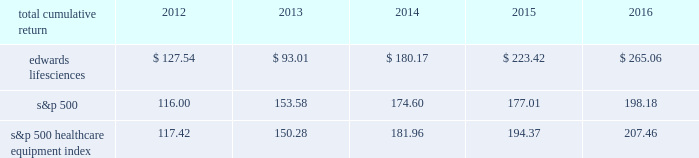2mar201707015999 ( c ) in october 2016 , our accelerated share repurchase ( 2018 2018asr 2019 2019 ) agreement concluded and we received an additional 44 thousand shares of our common stock .
Shares purchased pursuant to the asr agreement are presented in the table above in the periods in which they were received .
Performance graph the following graph compares the performance of our common stock with that of the s&p 500 index and the s&p 500 healthcare equipment index .
The cumulative total return listed below assumes an initial investment of $ 100 at the market close on december 30 , 2011 and reinvestment of dividends .
Comparison of 5 year cumulative total return 2011 2012 2016201520142013 edwards lifesciences corporation s&p 500 s&p 500 healthcare equipment index december 31 .

What was the percentage cumulative total return for edwards lifesciences for the five years ended 2016? 
Computations: ((265.06 - 100) / 100)
Answer: 1.6506. 